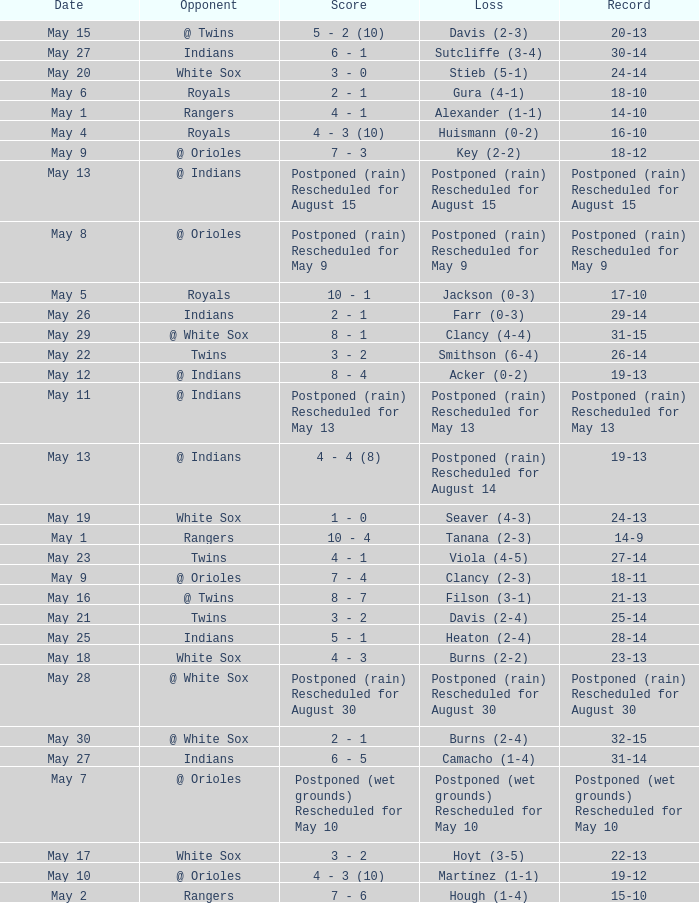What was the loss of the game when the record was 21-13? Filson (3-1). 